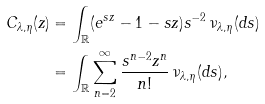Convert formula to latex. <formula><loc_0><loc_0><loc_500><loc_500>C _ { \lambda , \eta } ( z ) & = \int _ { \mathbb { R } } ( e ^ { s z } - 1 - s z ) s ^ { - 2 } \, \nu _ { \lambda , \eta } ( d s ) \\ & = \int _ { \mathbb { R } } \sum _ { n = 2 } ^ { \infty } \frac { s ^ { n - 2 } z ^ { n } } { n ! } \, \nu _ { \lambda , \eta } ( d s ) ,</formula> 